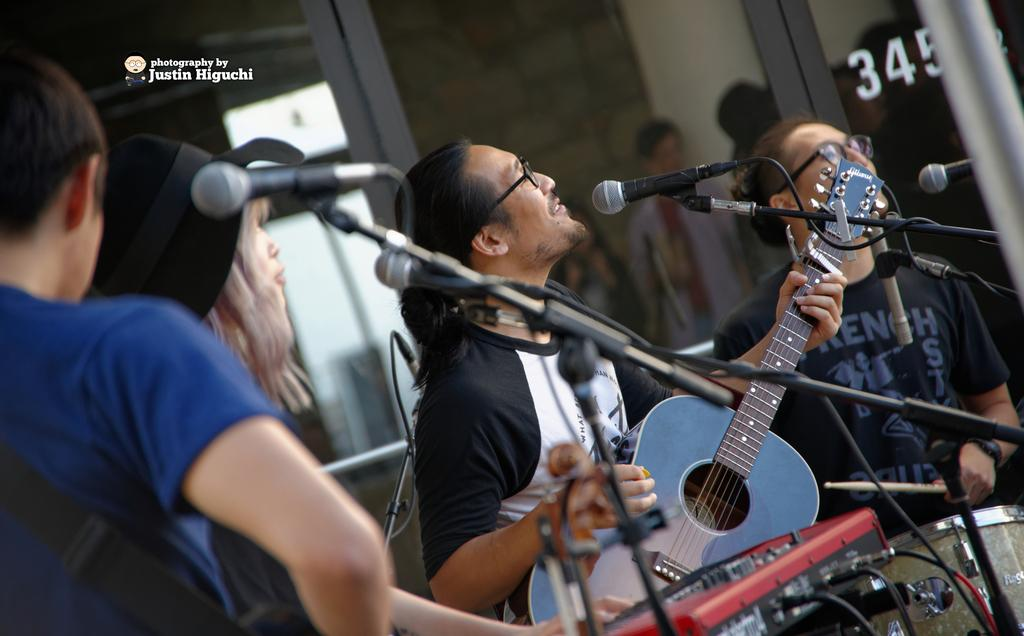How many people are in the image? There are four persons in the image. What are the four persons doing in the image? The four persons are playing musical instruments. Can you describe any equipment related to sound in the image? Yes, there is a microphone with a mic holder in the image. What position are the four persons in? The four persons are standing. What type of tax is being discussed by the four persons in the image? There is no indication in the image that the four persons are discussing any tax. Can you tell me how many bees are buzzing around the microphone in the image? There are no bees present in the image; the focus is on the four persons playing musical instruments and the microphone with a mic holder. 